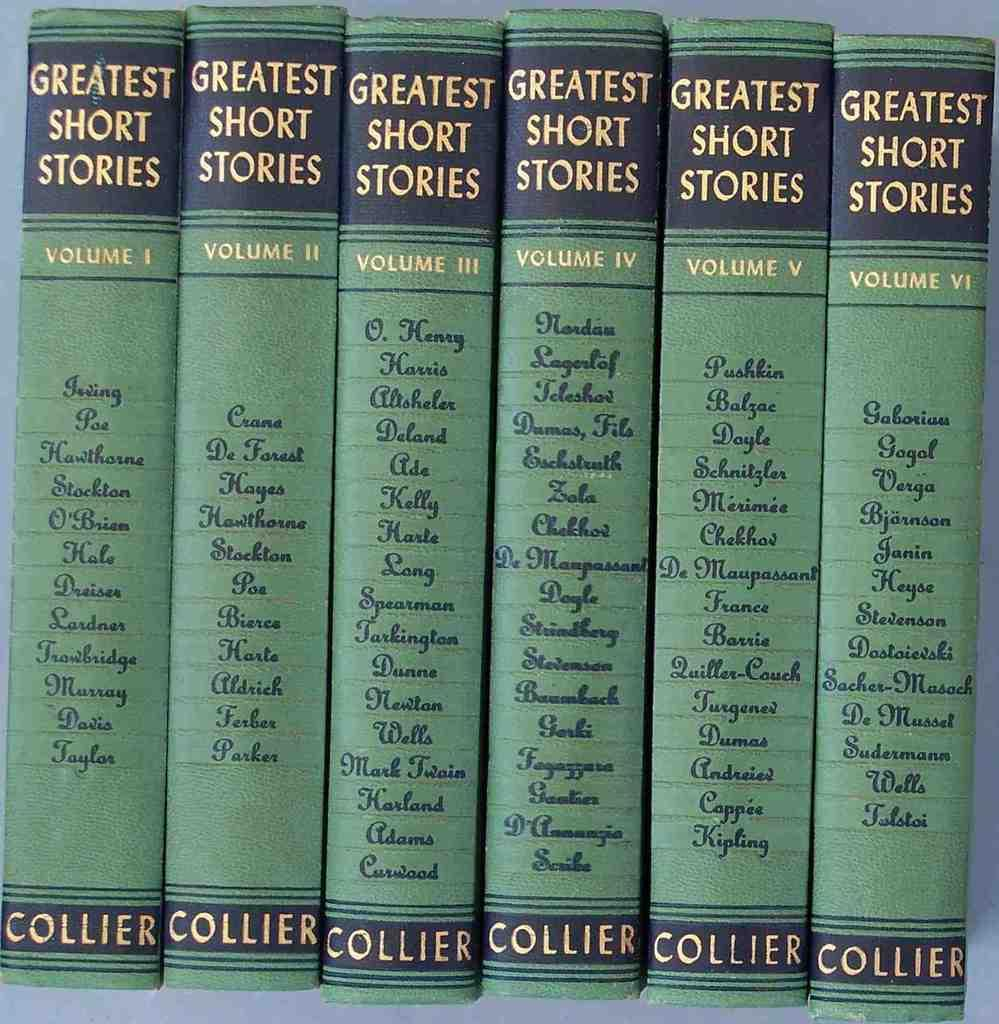<image>
Present a compact description of the photo's key features. A collection of volumes titled Greatest Short Stories. 